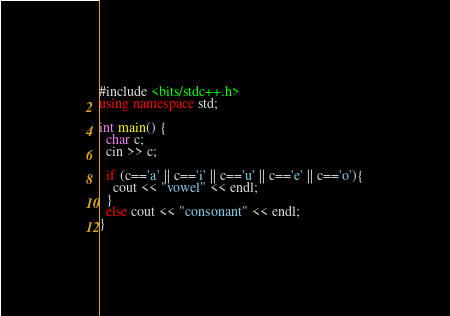<code> <loc_0><loc_0><loc_500><loc_500><_C++_>#include <bits/stdc++.h>
using namespace std;
 
int main() {
  char c;
  cin >> c;
  
  if (c=='a' || c=='i' || c=='u' || c=='e' || c=='o'){
    cout << "vowel" << endl;
  }
  else cout << "consonant" << endl;
}</code> 